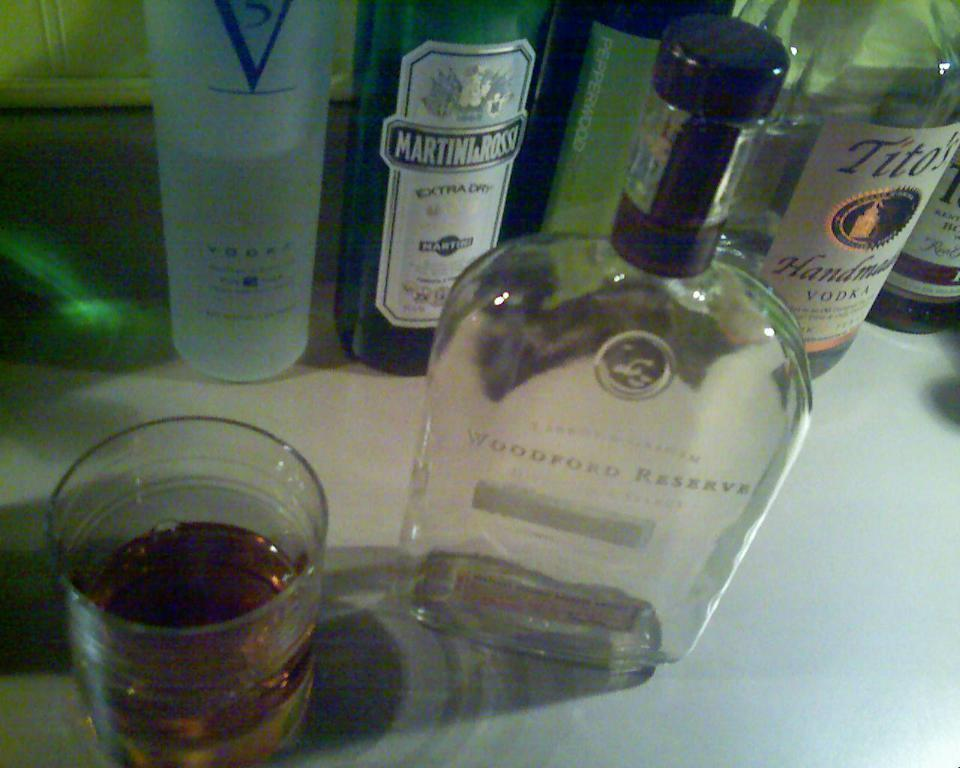<image>
Summarize the visual content of the image. An open bottle of Tito's next to some other bottles and a half full glass. 